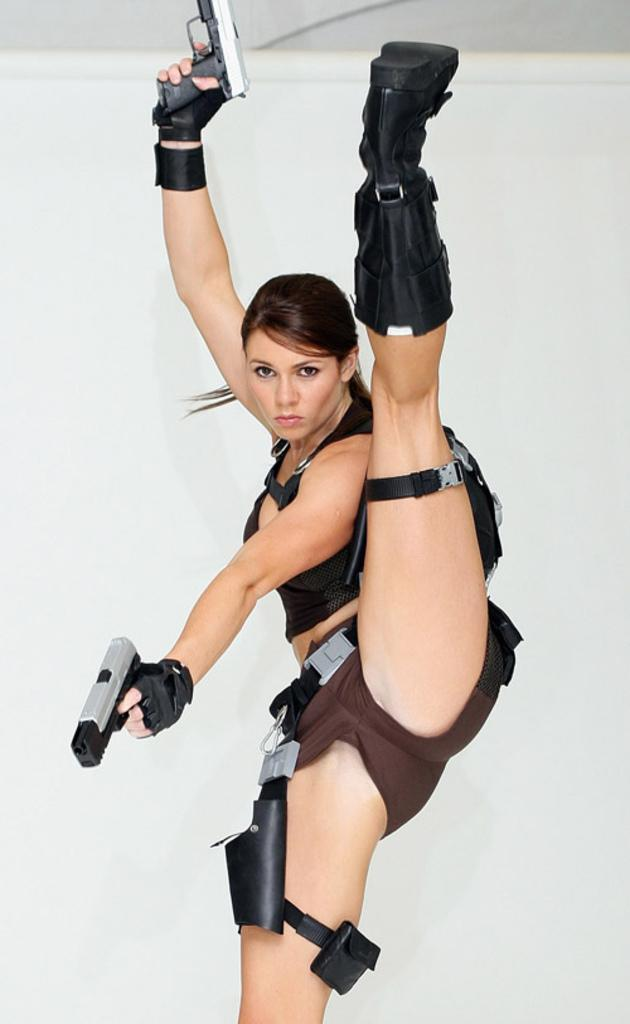Who is present in the image? There is a lady in the image. What is the lady holding in the image? The lady is holding two guns. What can be seen in the background of the image? There is a wall and a roof in the image. What is the size of the brass spot on the wall in the image? There is no brass spot present in the image, and therefore no size can be determined. 